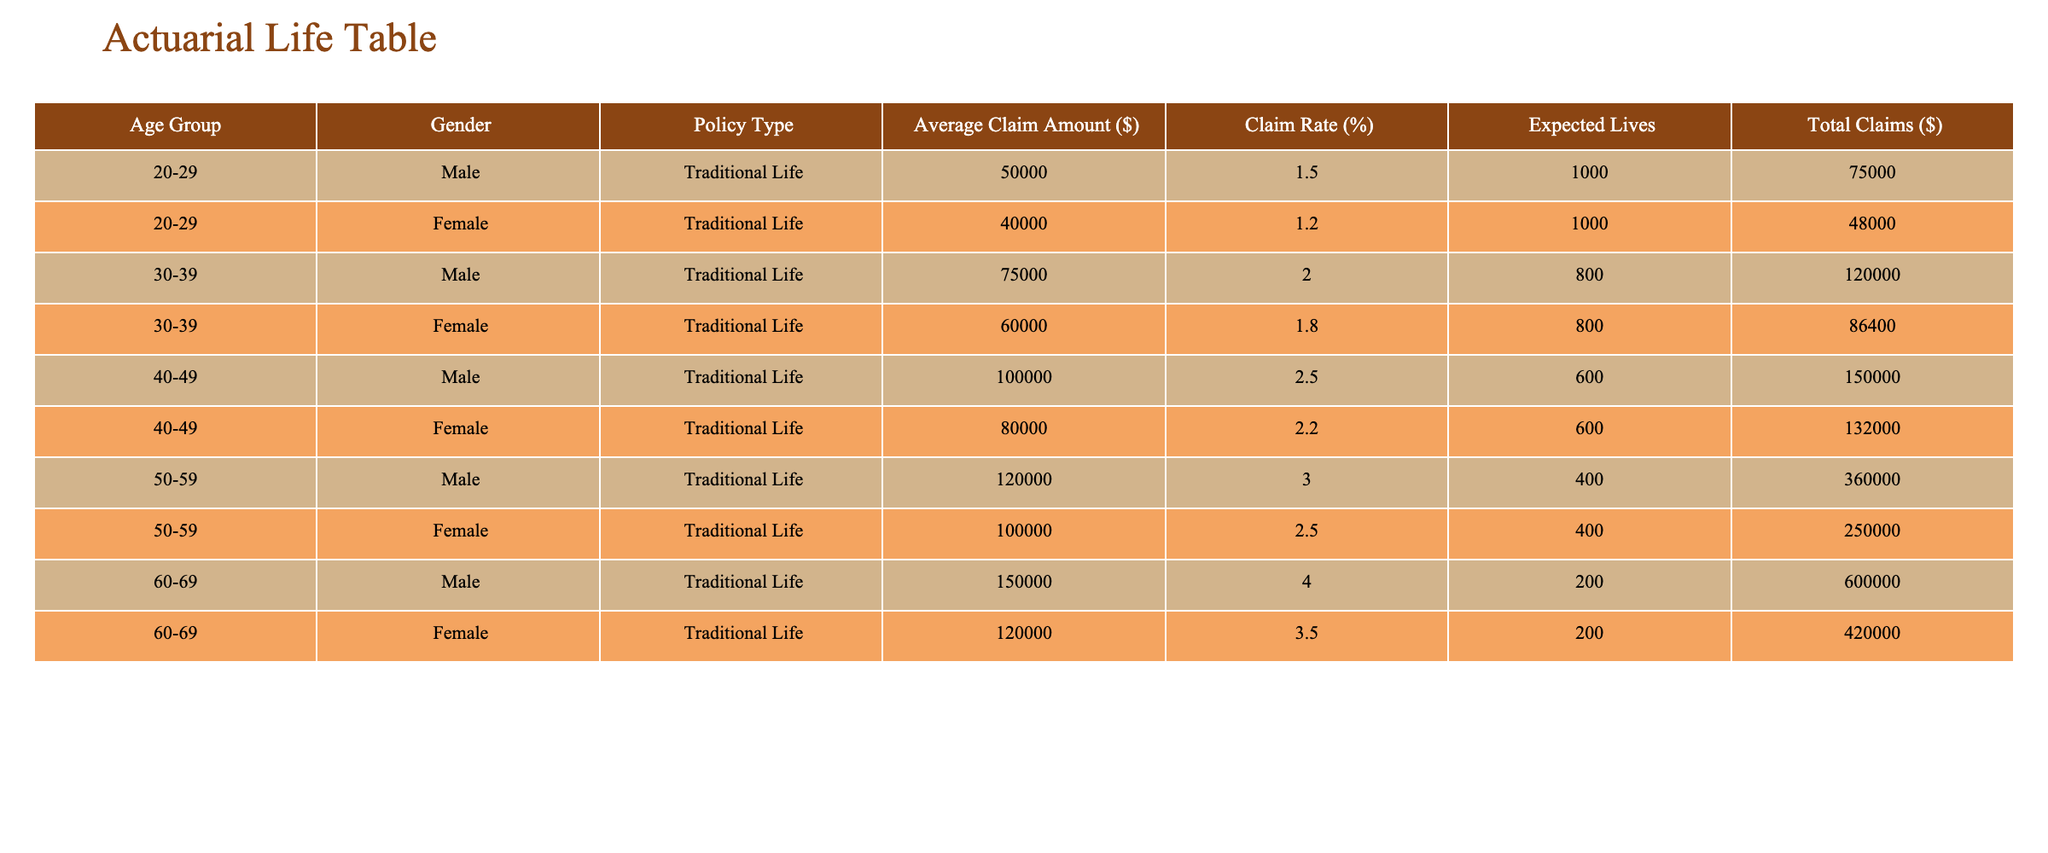What is the claim rate for females in the age group 30-39? From the table under the age group 30-39, the claim rate for females is listed as 1.8%.
Answer: 1.8% Which gender has a higher average claim amount in the age group 50-59? The average claim amount for males in this group is 120,000 dollars, while for females, it is 100,000 dollars. Therefore, males have a higher average claim amount.
Answer: Male What is the total claims amount for the age group 40-49? For this age group, males have total claims of 150,000 dollars and females have total claims of 132,000 dollars. Adding these together gives 150,000 + 132,000 = 282,000 dollars.
Answer: 282,000 What is the expected life count for males in the age group 20-29? The expected lives for males in this age group is 1,000, as stated directly in the table.
Answer: 1,000 Is the claim rate for females in the age group 60-69 higher than the claim rate for males in the same age group? The claim rate for males in this age group is 4.0%, whereas for females it is 3.5%, which shows that the claim rate for females is lower.
Answer: No What is the average expected lives across all age groups for females? The expected lives are 1,000 for age group 20-29, 800 for age group 30-39, 600 for age group 40-49, 400 for age group 50-59, and 200 for age group 60-69. Summing these gives 1,000 + 800 + 600 + 400 + 200 = 3,000. With 5 age groups, the average is 3,000 / 5 = 600.
Answer: 600 What is the difference in total claims between males and females in the age group 50-59? The total claims for males in this group are 360,000 dollars, and for females, it is 250,000 dollars. The difference is 360,000 - 250,000 = 110,000 dollars.
Answer: 110,000 Does any age group have a claim rate of more than 3% for males? Checking the claim rates for males: 1.5%, 2.0%, 2.5%, 3.0%, and 4.0%. The age group 60-69 has a claim rate of 4.0%, which is indeed more than 3%.
Answer: Yes What is the total average claim amount for females across all age groups? The average claim amounts for females by age group are 40,000, 60,000, 80,000, 100,000, and 120,000 dollars. Adding these gives 40,000 + 48,000 + 64,000 + 100,000 + 120,000 = 372,000. The total number of age groups is 5, so the average is 372,000 / 5 = 74,400 dollars.
Answer: 74,400 